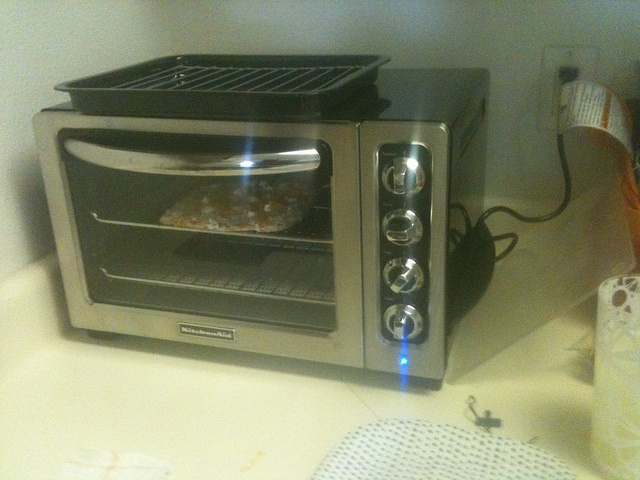Describe the objects in this image and their specific colors. I can see microwave in lightgray, darkgreen, gray, black, and olive tones, cup in lightgray, tan, and khaki tones, and pizza in lightgray, darkgreen, black, and gray tones in this image. 